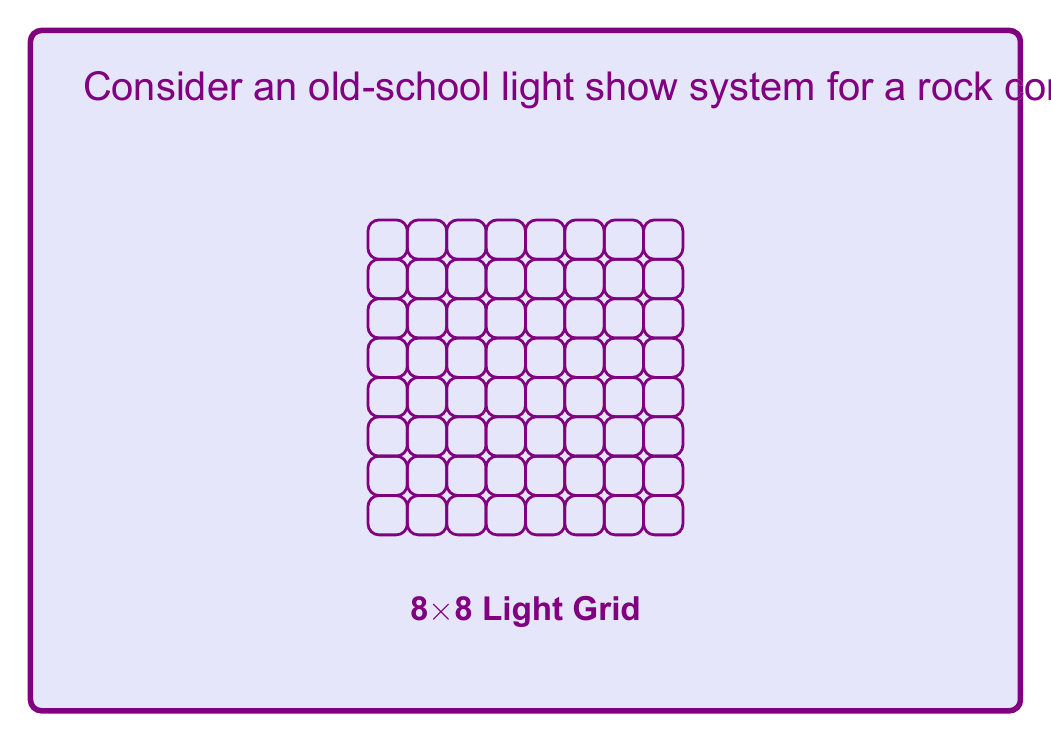Solve this math problem. Let's break this down step-by-step:

1) First, we need to understand what the algorithm is doing:
   - It's processing each light in the 8x8 grid.
   - For each light, it's making a random decision (coin flip).

2) Now, let's count the number of operations:
   - The grid size is 8x8, so there are 64 lights in total.
   - The algorithm processes each light once.
   - For each light, it performs one operation (the coin flip and state setting).

3) Therefore, the total number of operations is:
   $$ 8 * 8 = 64 $$

4) In computational complexity theory, we're interested in how the algorithm scales with input size. Let's generalize this to an NxN grid:
   - The number of operations would be $N * N = N^2$

5) The time complexity is thus $O(N^2)$, where N is the side length of the grid.

6) However, in this specific case, N is a constant (8). When dealing with constant input sizes, the time complexity is technically $O(1)$, as it doesn't grow with input size.

7) But from a practical perspective, considering variable grid sizes, the complexity would be $O(N^2)$ or $O(m)$ where m is the total number of lights.
Answer: $O(1)$ for the specific 8x8 grid; $O(N^2)$ for variable NxN grids 